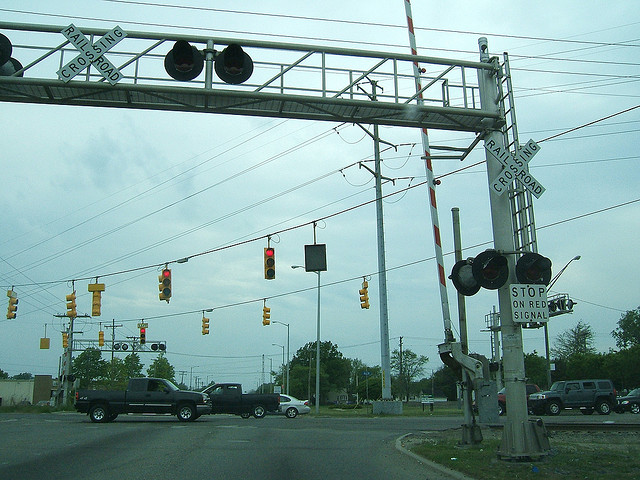Extract all visible text content from this image. RAIL RAIL ROAD CROSSING ROAD STOP ON 